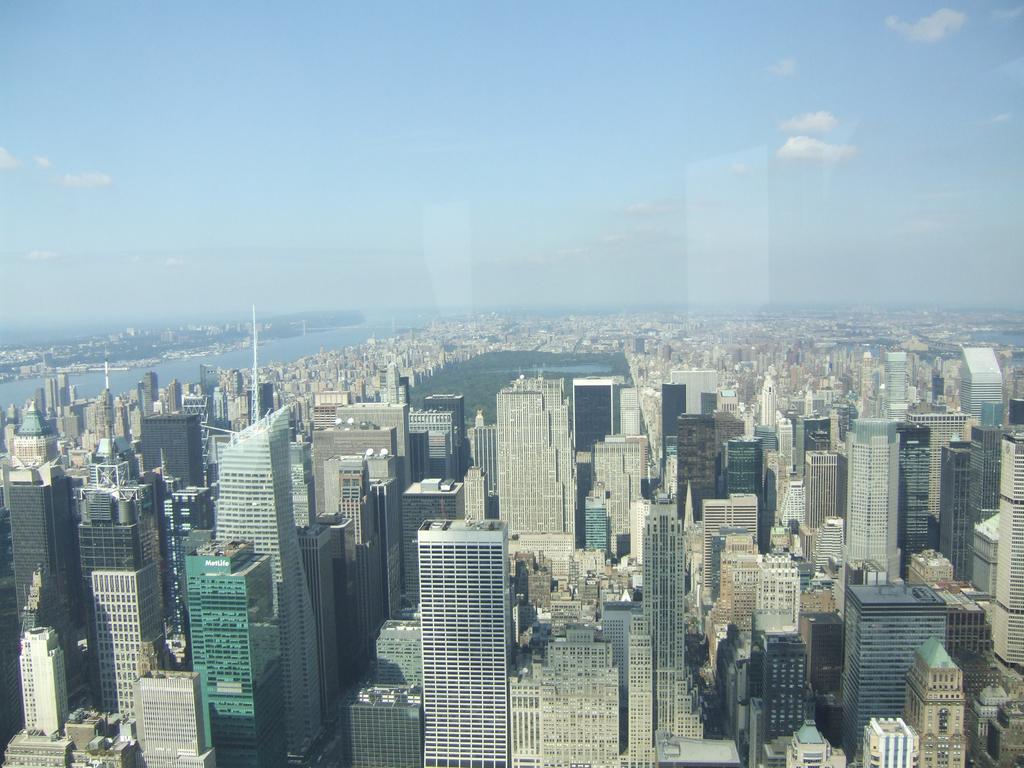Describe this image in one or two sentences. In this picture we can see many skyscrapers and buildings. Here we can see some towers. On the left background we can see water. On the top we can see sky and clouds. In the center we can see trees. 